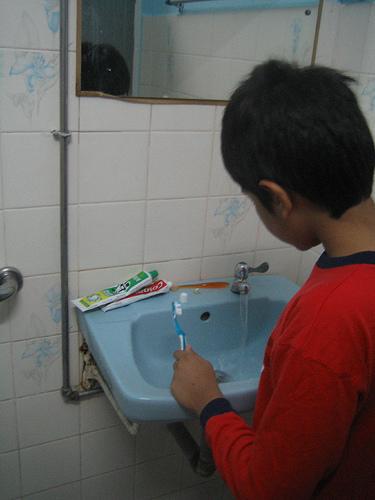What color is the sink?
Concise answer only. Blue. What is the boy doing?
Short answer required. Brushing teeth. How many toothbrushes is this?
Answer briefly. 2. Is there a mirror?
Answer briefly. Yes. How many tubes of toothpaste are on the sink?
Be succinct. 2. Is there a cat in the sink?
Keep it brief. No. What is in the sink?
Give a very brief answer. Water. 